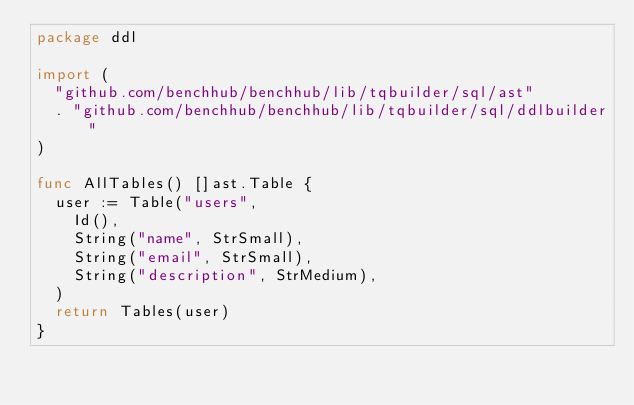<code> <loc_0><loc_0><loc_500><loc_500><_Go_>package ddl

import (
	"github.com/benchhub/benchhub/lib/tqbuilder/sql/ast"
	. "github.com/benchhub/benchhub/lib/tqbuilder/sql/ddlbuilder"
)

func AllTables() []ast.Table {
	user := Table("users",
		Id(),
		String("name", StrSmall),
		String("email", StrSmall),
		String("description", StrMedium),
	)
	return Tables(user)
}
</code> 